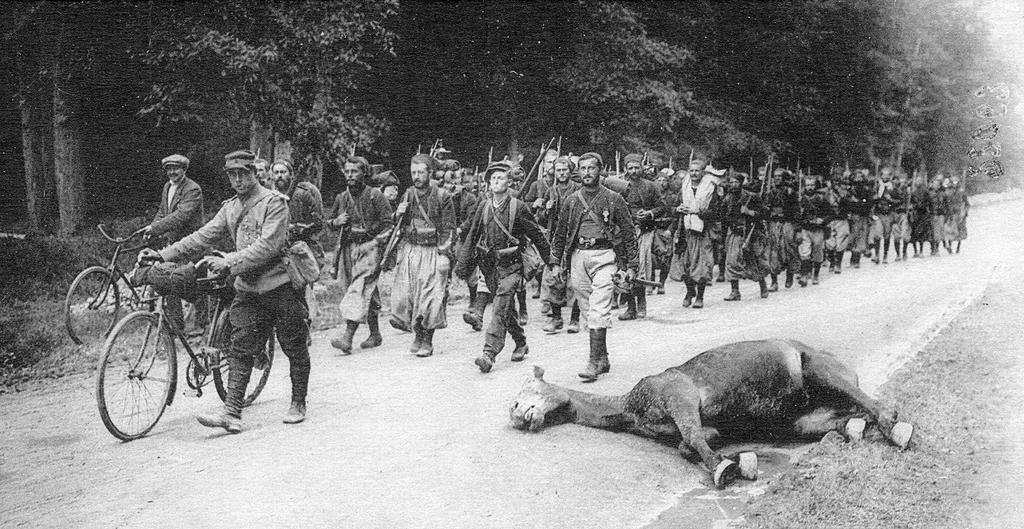Could you give a brief overview of what you see in this image? In the center of the image there are people walking. They are all wearing costumes. On the left there are two people holding bicycles. In the background there are trees. At the bottom there is an animal lying on the road. 